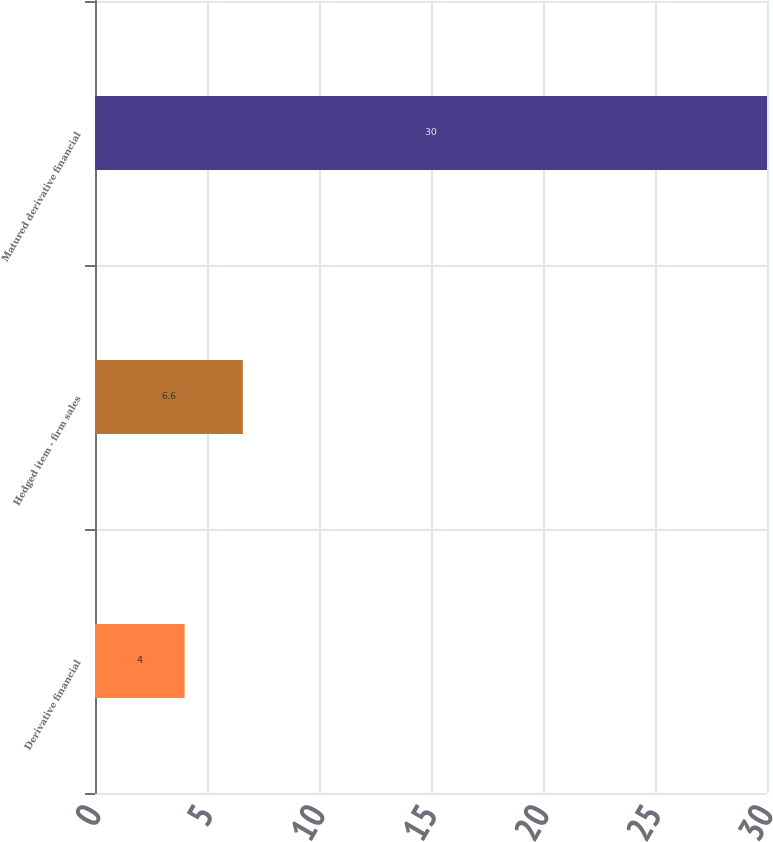<chart> <loc_0><loc_0><loc_500><loc_500><bar_chart><fcel>Derivative financial<fcel>Hedged item - firm sales<fcel>Matured derivative financial<nl><fcel>4<fcel>6.6<fcel>30<nl></chart> 